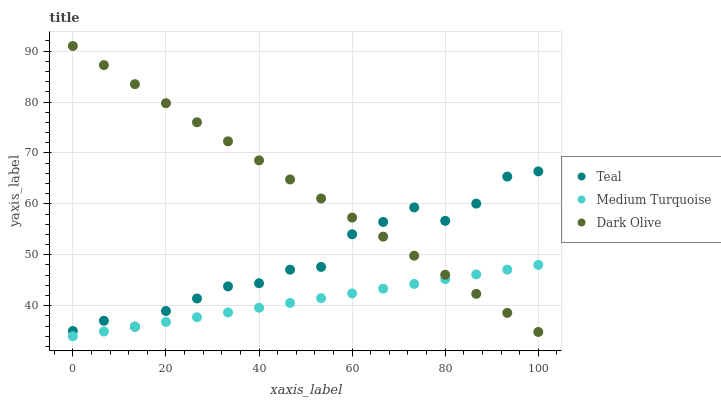Does Medium Turquoise have the minimum area under the curve?
Answer yes or no. Yes. Does Dark Olive have the maximum area under the curve?
Answer yes or no. Yes. Does Teal have the minimum area under the curve?
Answer yes or no. No. Does Teal have the maximum area under the curve?
Answer yes or no. No. Is Medium Turquoise the smoothest?
Answer yes or no. Yes. Is Teal the roughest?
Answer yes or no. Yes. Is Teal the smoothest?
Answer yes or no. No. Is Medium Turquoise the roughest?
Answer yes or no. No. Does Medium Turquoise have the lowest value?
Answer yes or no. Yes. Does Teal have the lowest value?
Answer yes or no. No. Does Dark Olive have the highest value?
Answer yes or no. Yes. Does Teal have the highest value?
Answer yes or no. No. Is Medium Turquoise less than Teal?
Answer yes or no. Yes. Is Teal greater than Medium Turquoise?
Answer yes or no. Yes. Does Dark Olive intersect Teal?
Answer yes or no. Yes. Is Dark Olive less than Teal?
Answer yes or no. No. Is Dark Olive greater than Teal?
Answer yes or no. No. Does Medium Turquoise intersect Teal?
Answer yes or no. No. 